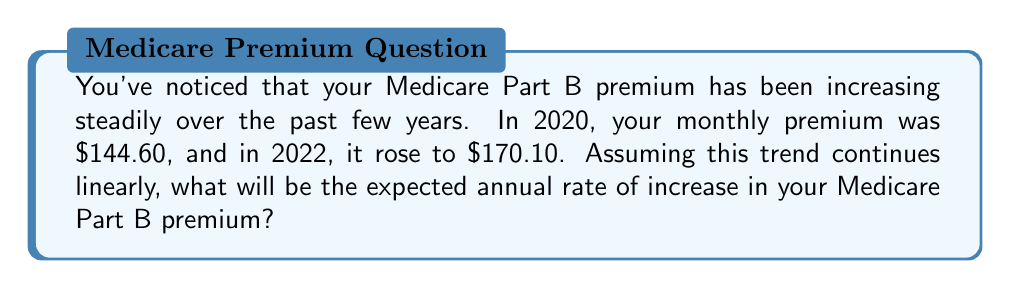What is the answer to this math problem? To solve this problem, we'll use a linear equation to determine the rate of change. Let's follow these steps:

1) First, let's identify our known points:
   $(x_1, y_1) = (2020, 144.60)$
   $(x_2, y_2) = (2022, 170.10)$

2) The rate of change (slope) formula is:
   $m = \frac{y_2 - y_1}{x_2 - x_1}$

3) Let's plug in our values:
   $m = \frac{170.10 - 144.60}{2022 - 2020}$

4) Simplify:
   $m = \frac{25.50}{2} = 12.75$

5) This means the premium increases by $12.75 per year.

6) To express this as an annual rate of increase, we need to consider the initial value:
   Annual rate of increase = $\frac{\text{Yearly increase}}{\text{Initial value}} \times 100\%$

7) Plugging in our values:
   Annual rate of increase = $\frac{12.75}{144.60} \times 100\% \approx 8.82\%$

Therefore, the expected annual rate of increase in your Medicare Part B premium is approximately 8.82%.
Answer: 8.82% 